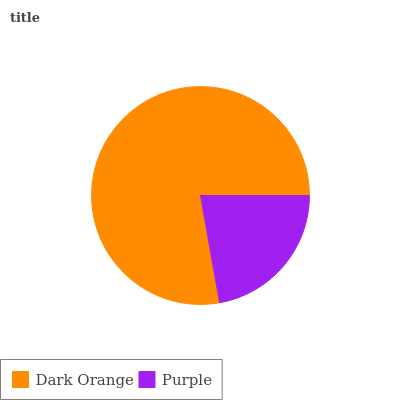Is Purple the minimum?
Answer yes or no. Yes. Is Dark Orange the maximum?
Answer yes or no. Yes. Is Purple the maximum?
Answer yes or no. No. Is Dark Orange greater than Purple?
Answer yes or no. Yes. Is Purple less than Dark Orange?
Answer yes or no. Yes. Is Purple greater than Dark Orange?
Answer yes or no. No. Is Dark Orange less than Purple?
Answer yes or no. No. Is Dark Orange the high median?
Answer yes or no. Yes. Is Purple the low median?
Answer yes or no. Yes. Is Purple the high median?
Answer yes or no. No. Is Dark Orange the low median?
Answer yes or no. No. 